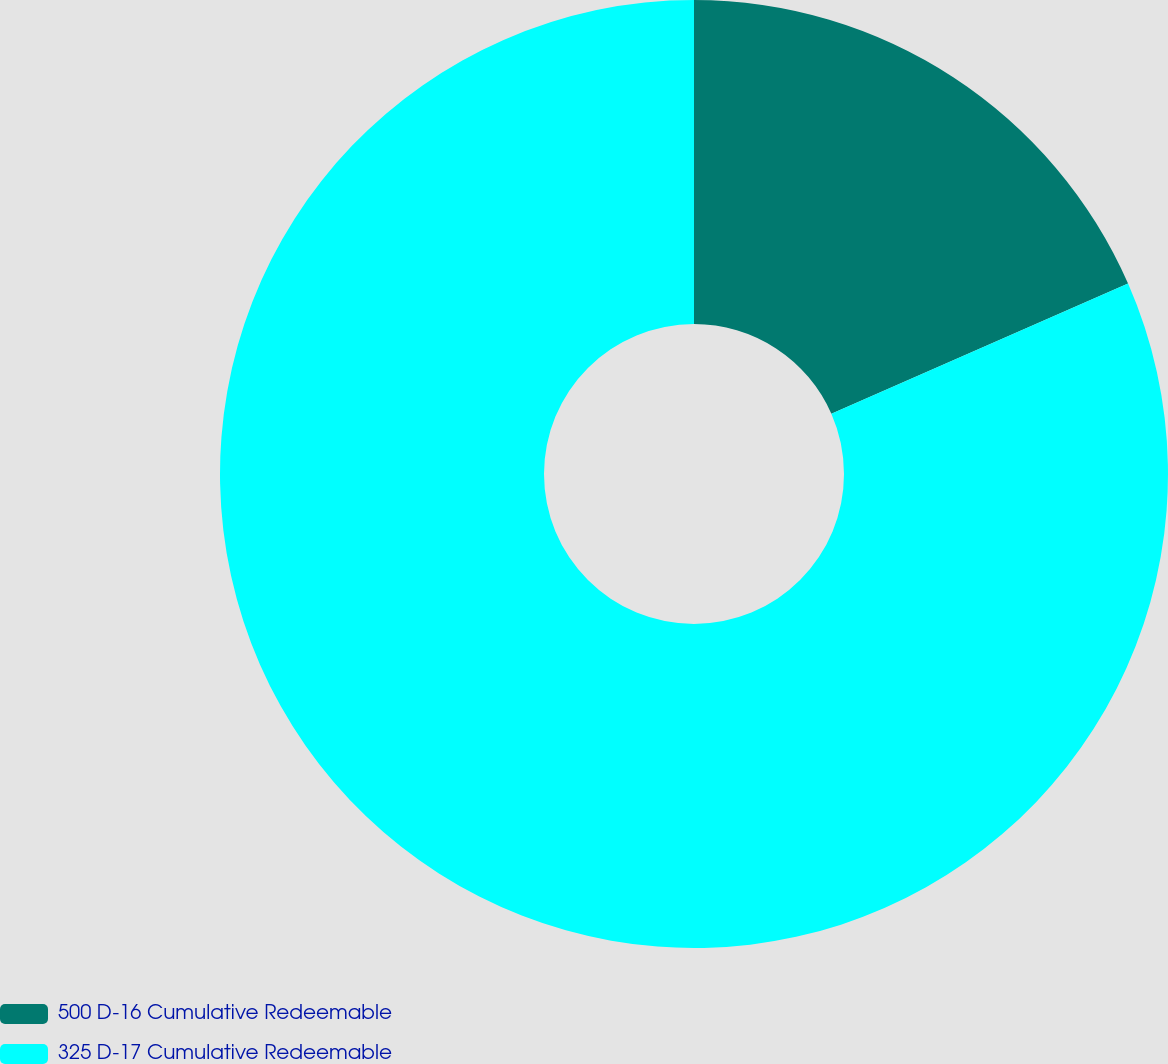Convert chart to OTSL. <chart><loc_0><loc_0><loc_500><loc_500><pie_chart><fcel>500 D-16 Cumulative Redeemable<fcel>325 D-17 Cumulative Redeemable<nl><fcel>18.42%<fcel>81.58%<nl></chart> 